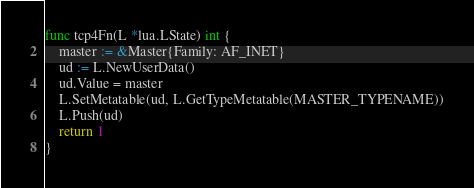Convert code to text. <code><loc_0><loc_0><loc_500><loc_500><_Go_>func tcp4Fn(L *lua.LState) int {
	master := &Master{Family: AF_INET}
	ud := L.NewUserData()
	ud.Value = master
	L.SetMetatable(ud, L.GetTypeMetatable(MASTER_TYPENAME))
	L.Push(ud)
	return 1
}
</code> 